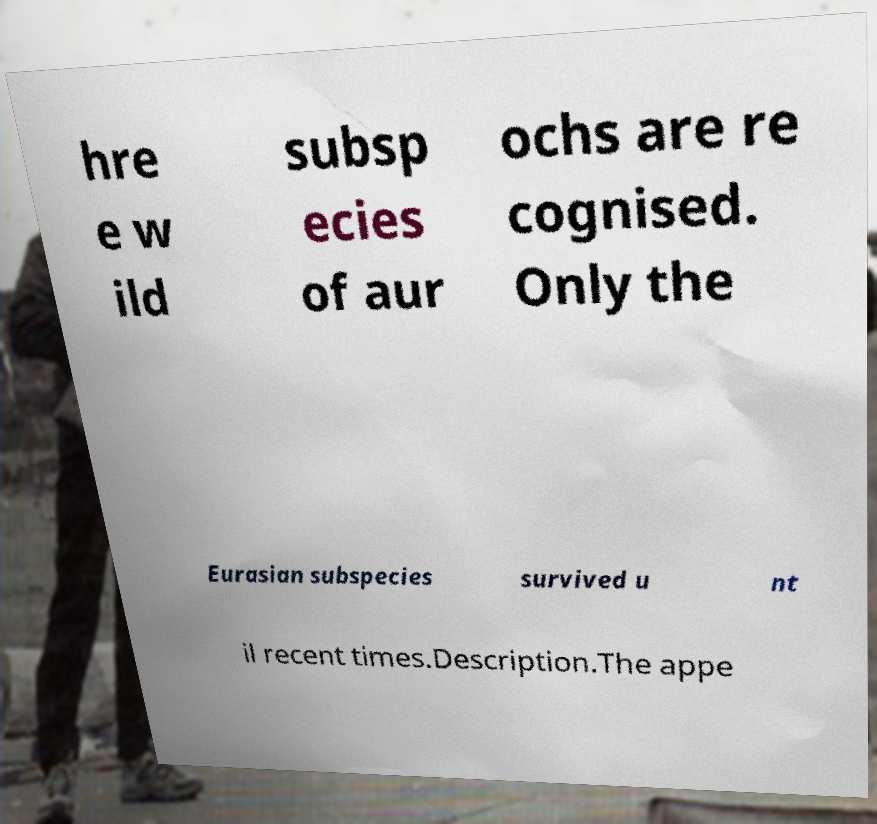Could you extract and type out the text from this image? hre e w ild subsp ecies of aur ochs are re cognised. Only the Eurasian subspecies survived u nt il recent times.Description.The appe 